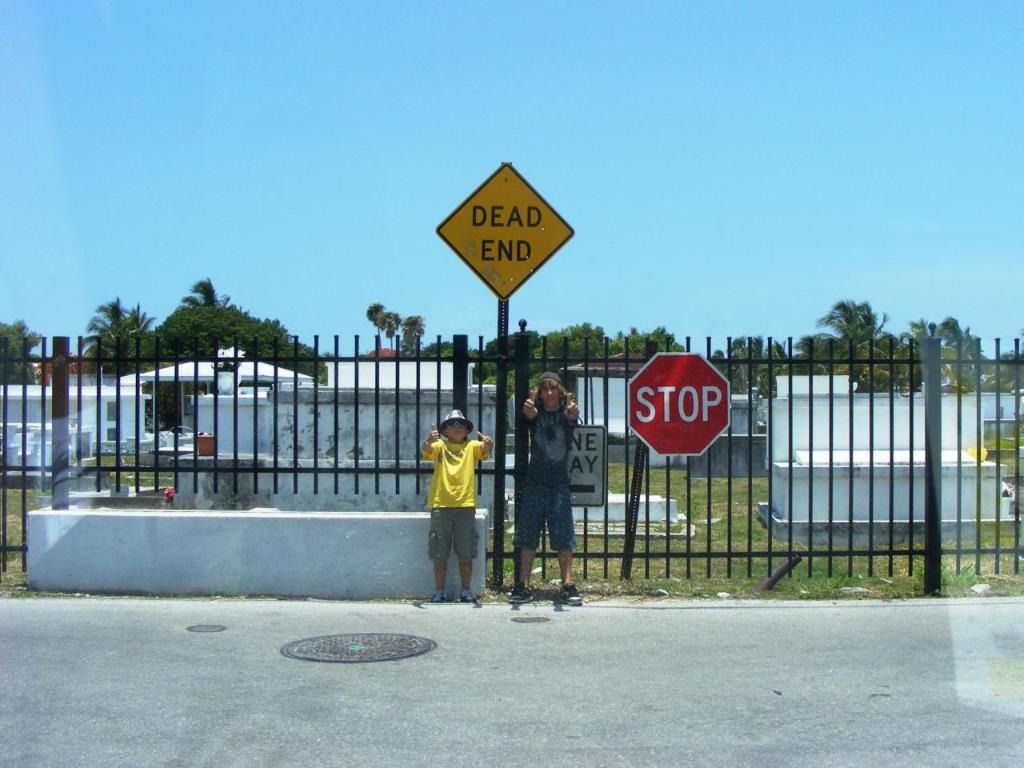<image>
Provide a brief description of the given image. a child and an adulat man are posing for a picture next to a sign that reads dead end and in front of a cemetery. 